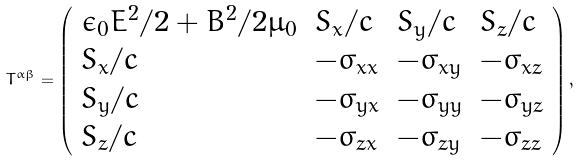<formula> <loc_0><loc_0><loc_500><loc_500>T ^ { \alpha \beta } = { \left ( \begin{array} { l l l l } { \epsilon _ { 0 } E ^ { 2 } / 2 + B ^ { 2 } / 2 \mu _ { 0 } } & { S _ { x } / c } & { S _ { y } / c } & { S _ { z } / c } \\ { S _ { x } / c } & { - \sigma _ { x x } } & { - \sigma _ { x y } } & { - \sigma _ { x z } } \\ { S _ { y } / c } & { - \sigma _ { y x } } & { - \sigma _ { y y } } & { - \sigma _ { y z } } \\ { S _ { z } / c } & { - \sigma _ { z x } } & { - \sigma _ { z y } } & { - \sigma _ { z z } } \end{array} \right ) } \, ,</formula> 